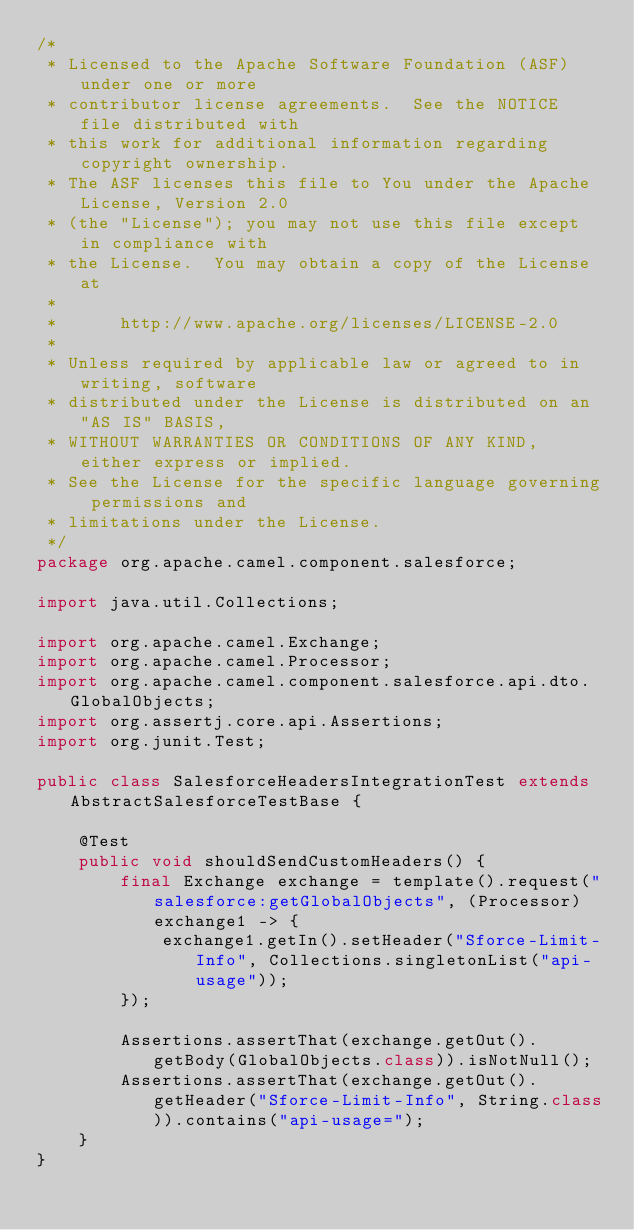<code> <loc_0><loc_0><loc_500><loc_500><_Java_>/*
 * Licensed to the Apache Software Foundation (ASF) under one or more
 * contributor license agreements.  See the NOTICE file distributed with
 * this work for additional information regarding copyright ownership.
 * The ASF licenses this file to You under the Apache License, Version 2.0
 * (the "License"); you may not use this file except in compliance with
 * the License.  You may obtain a copy of the License at
 *
 *      http://www.apache.org/licenses/LICENSE-2.0
 *
 * Unless required by applicable law or agreed to in writing, software
 * distributed under the License is distributed on an "AS IS" BASIS,
 * WITHOUT WARRANTIES OR CONDITIONS OF ANY KIND, either express or implied.
 * See the License for the specific language governing permissions and
 * limitations under the License.
 */
package org.apache.camel.component.salesforce;

import java.util.Collections;

import org.apache.camel.Exchange;
import org.apache.camel.Processor;
import org.apache.camel.component.salesforce.api.dto.GlobalObjects;
import org.assertj.core.api.Assertions;
import org.junit.Test;

public class SalesforceHeadersIntegrationTest extends AbstractSalesforceTestBase {

    @Test
    public void shouldSendCustomHeaders() {
        final Exchange exchange = template().request("salesforce:getGlobalObjects", (Processor) exchange1 -> {
            exchange1.getIn().setHeader("Sforce-Limit-Info", Collections.singletonList("api-usage"));
        });

        Assertions.assertThat(exchange.getOut().getBody(GlobalObjects.class)).isNotNull();
        Assertions.assertThat(exchange.getOut().getHeader("Sforce-Limit-Info", String.class)).contains("api-usage=");
    }
}
</code> 